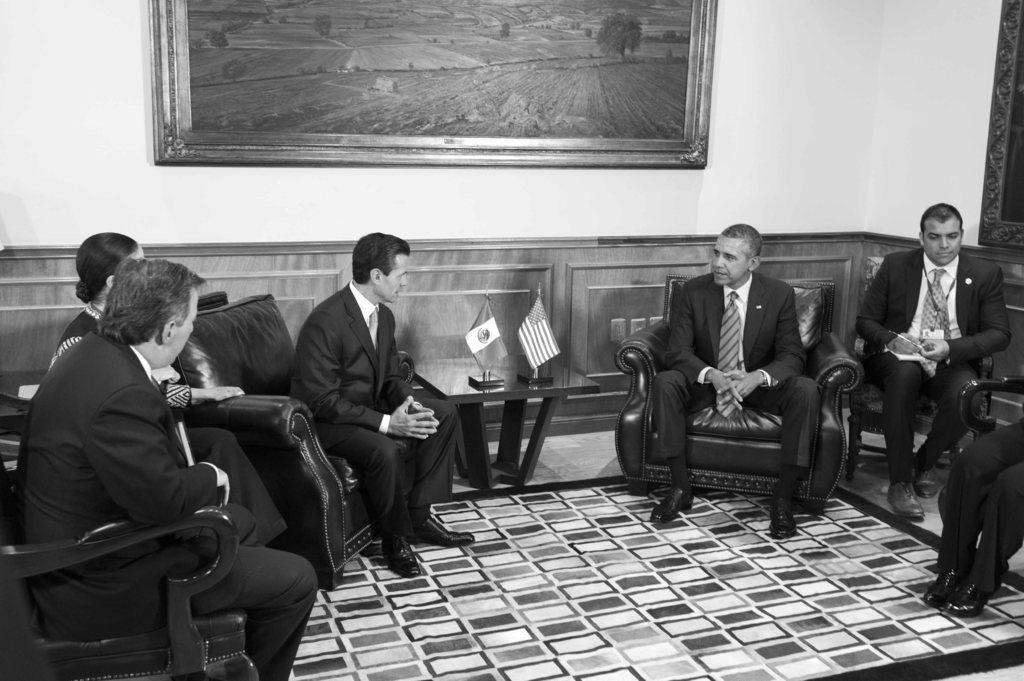How would you summarize this image in a sentence or two? In the picture we can see some people are sitting on the chairs and they are in blazers, ties and shirts and in front of them, we can see a floor mat and between the people we can see a table with two flags and behind them we can see the wall with a photo frame and a painting of scenery on it. 